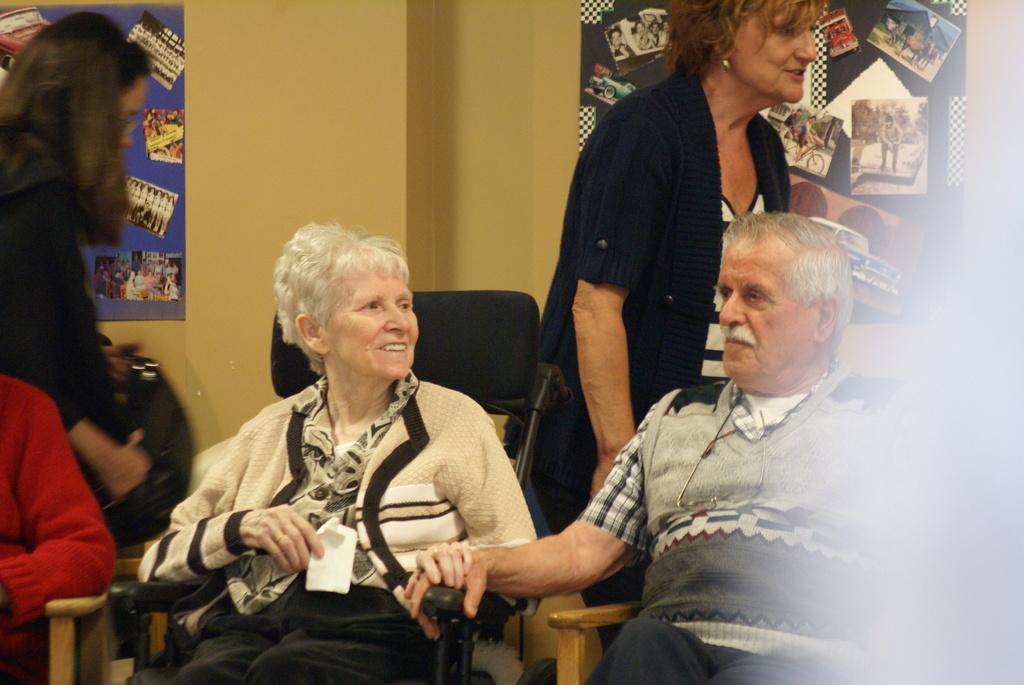How many people are sitting in the image? There are three persons sitting on chairs in the image. Are there any other people visible in the image? Yes, there are two persons standing in the background. What can be seen in the background behind the people? There is a wall in the background. What is hanging on the wall? There are photo frames on the wall. Can you see any islands in the image? There are no islands visible in the image. Is there a light source illuminating the people in the image? The provided facts do not mention any light source, so we cannot determine if there is one in the image. 